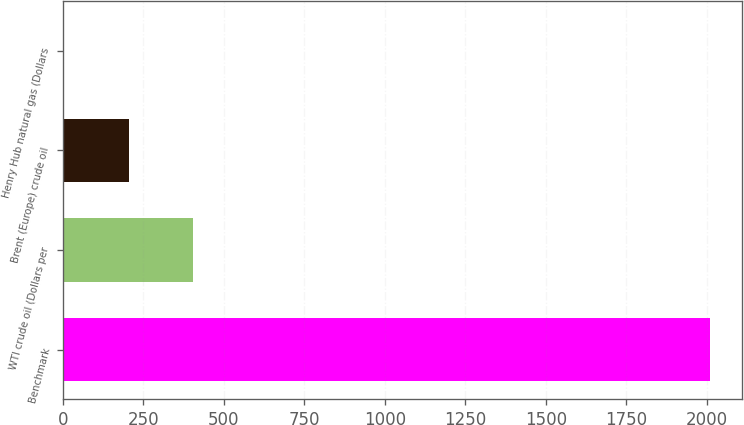Convert chart. <chart><loc_0><loc_0><loc_500><loc_500><bar_chart><fcel>Benchmark<fcel>WTI crude oil (Dollars per<fcel>Brent (Europe) crude oil<fcel>Henry Hub natural gas (Dollars<nl><fcel>2010<fcel>405.51<fcel>204.95<fcel>4.39<nl></chart> 